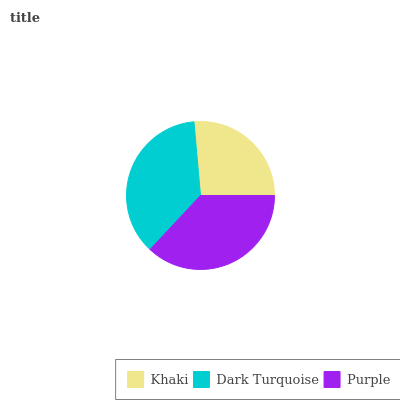Is Khaki the minimum?
Answer yes or no. Yes. Is Purple the maximum?
Answer yes or no. Yes. Is Dark Turquoise the minimum?
Answer yes or no. No. Is Dark Turquoise the maximum?
Answer yes or no. No. Is Dark Turquoise greater than Khaki?
Answer yes or no. Yes. Is Khaki less than Dark Turquoise?
Answer yes or no. Yes. Is Khaki greater than Dark Turquoise?
Answer yes or no. No. Is Dark Turquoise less than Khaki?
Answer yes or no. No. Is Dark Turquoise the high median?
Answer yes or no. Yes. Is Dark Turquoise the low median?
Answer yes or no. Yes. Is Khaki the high median?
Answer yes or no. No. Is Purple the low median?
Answer yes or no. No. 